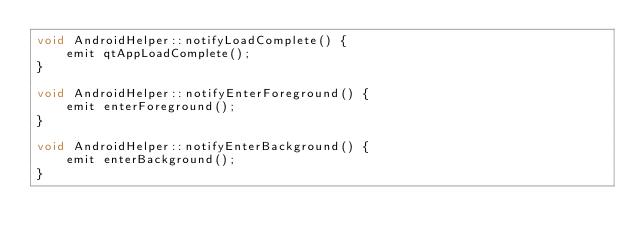Convert code to text. <code><loc_0><loc_0><loc_500><loc_500><_C++_>void AndroidHelper::notifyLoadComplete() {
    emit qtAppLoadComplete();
}

void AndroidHelper::notifyEnterForeground() {
    emit enterForeground();
}

void AndroidHelper::notifyEnterBackground() {
    emit enterBackground();
}

</code> 